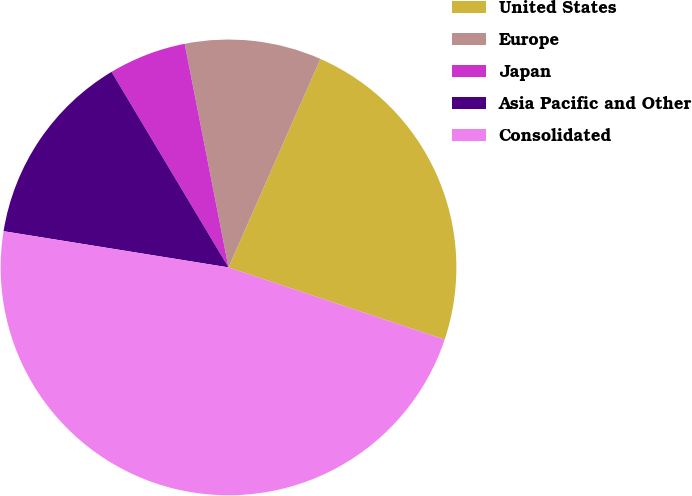Convert chart. <chart><loc_0><loc_0><loc_500><loc_500><pie_chart><fcel>United States<fcel>Europe<fcel>Japan<fcel>Asia Pacific and Other<fcel>Consolidated<nl><fcel>23.52%<fcel>9.69%<fcel>5.5%<fcel>13.88%<fcel>47.41%<nl></chart> 